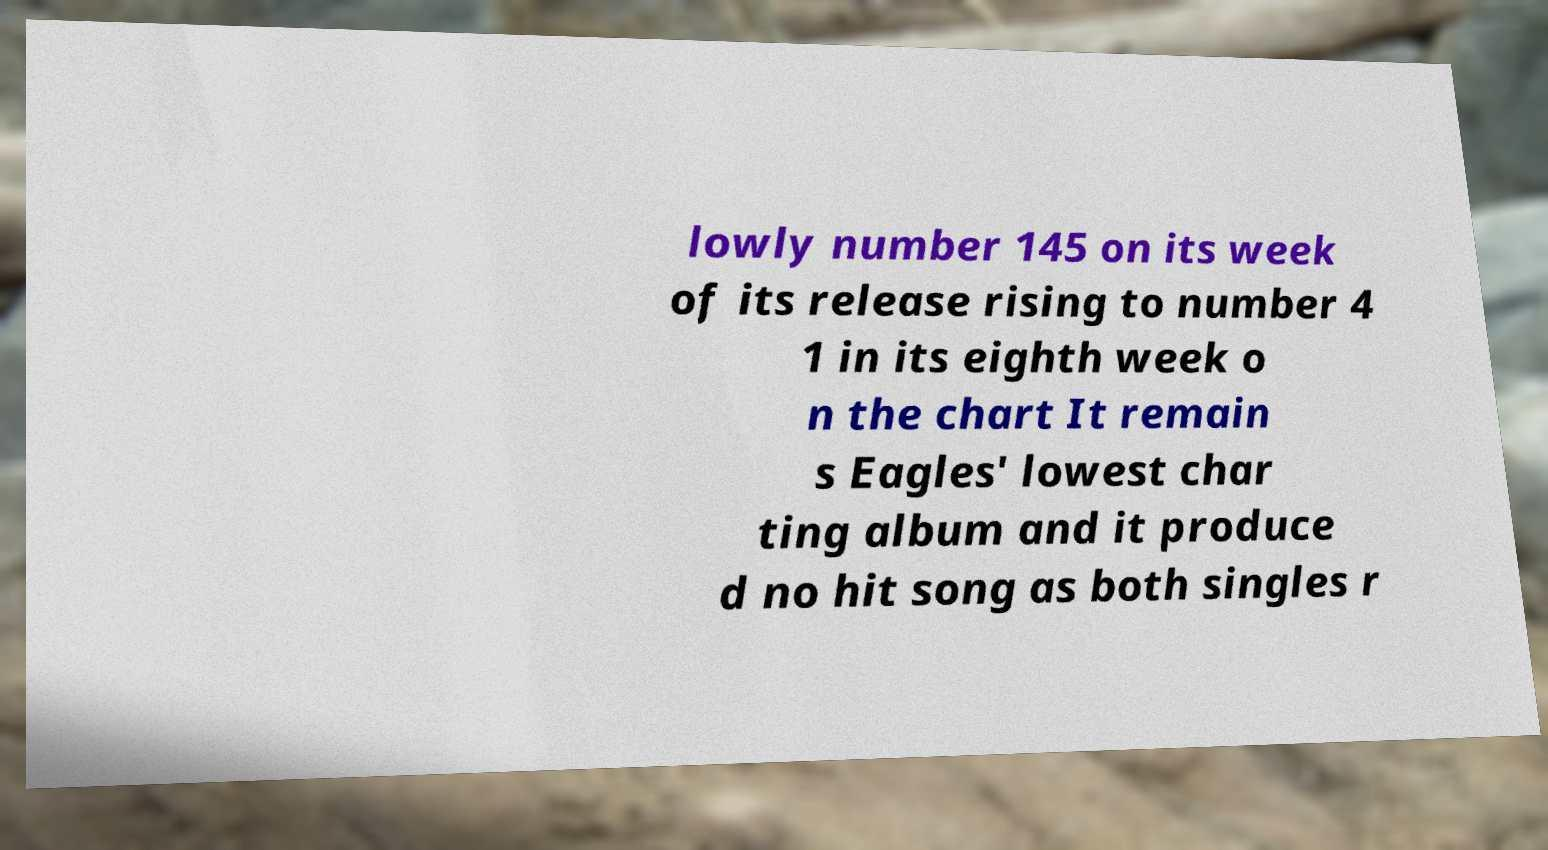Could you assist in decoding the text presented in this image and type it out clearly? lowly number 145 on its week of its release rising to number 4 1 in its eighth week o n the chart It remain s Eagles' lowest char ting album and it produce d no hit song as both singles r 